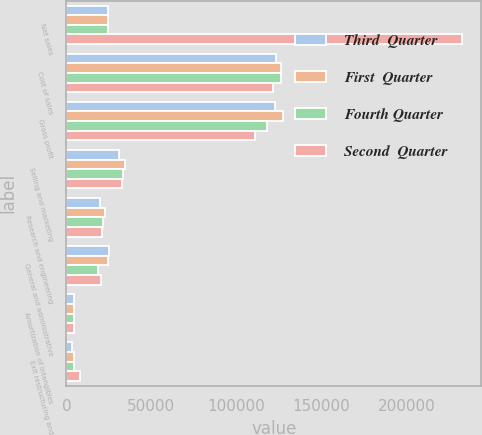<chart> <loc_0><loc_0><loc_500><loc_500><stacked_bar_chart><ecel><fcel>Net sales<fcel>Cost of sales<fcel>Gross profit<fcel>Selling and marketing<fcel>Research and engineering<fcel>General and administrative<fcel>Amortization of intangibles<fcel>Exit restructuring and<nl><fcel>Third  Quarter<fcel>24216<fcel>123362<fcel>122915<fcel>30861<fcel>19907<fcel>25045<fcel>4514<fcel>3234<nl><fcel>First  Quarter<fcel>24216<fcel>126067<fcel>127715<fcel>34322<fcel>22849<fcel>24216<fcel>4679<fcel>4680<nl><fcel>Fourth Quarter<fcel>24216<fcel>126287<fcel>117786<fcel>33148<fcel>21711<fcel>18534<fcel>4711<fcel>4304<nl><fcel>Second  Quarter<fcel>232568<fcel>121679<fcel>110889<fcel>32433<fcel>20653<fcel>20090<fcel>4671<fcel>7791<nl></chart> 